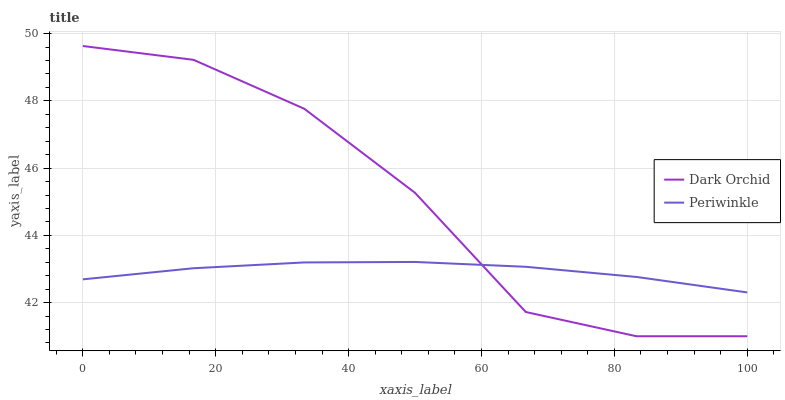Does Periwinkle have the minimum area under the curve?
Answer yes or no. Yes. Does Dark Orchid have the maximum area under the curve?
Answer yes or no. Yes. Does Dark Orchid have the minimum area under the curve?
Answer yes or no. No. Is Periwinkle the smoothest?
Answer yes or no. Yes. Is Dark Orchid the roughest?
Answer yes or no. Yes. Is Dark Orchid the smoothest?
Answer yes or no. No. Does Dark Orchid have the lowest value?
Answer yes or no. Yes. Does Dark Orchid have the highest value?
Answer yes or no. Yes. Does Dark Orchid intersect Periwinkle?
Answer yes or no. Yes. Is Dark Orchid less than Periwinkle?
Answer yes or no. No. Is Dark Orchid greater than Periwinkle?
Answer yes or no. No. 